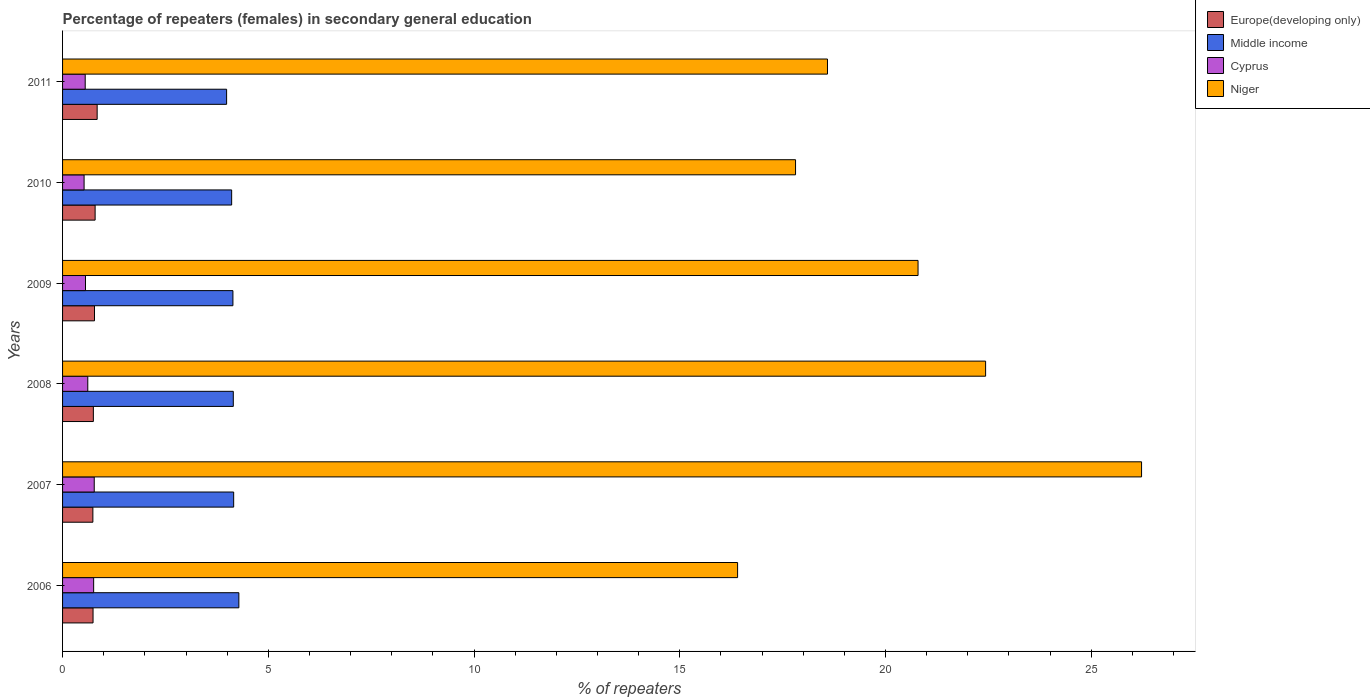How many different coloured bars are there?
Make the answer very short. 4. How many groups of bars are there?
Keep it short and to the point. 6. Are the number of bars per tick equal to the number of legend labels?
Provide a short and direct response. Yes. What is the label of the 3rd group of bars from the top?
Make the answer very short. 2009. What is the percentage of female repeaters in Europe(developing only) in 2008?
Keep it short and to the point. 0.75. Across all years, what is the maximum percentage of female repeaters in Europe(developing only)?
Your answer should be compact. 0.84. Across all years, what is the minimum percentage of female repeaters in Cyprus?
Make the answer very short. 0.52. What is the total percentage of female repeaters in Cyprus in the graph?
Your response must be concise. 3.77. What is the difference between the percentage of female repeaters in Cyprus in 2007 and that in 2009?
Keep it short and to the point. 0.21. What is the difference between the percentage of female repeaters in Cyprus in 2009 and the percentage of female repeaters in Niger in 2007?
Keep it short and to the point. -25.67. What is the average percentage of female repeaters in Niger per year?
Provide a succinct answer. 20.38. In the year 2007, what is the difference between the percentage of female repeaters in Niger and percentage of female repeaters in Europe(developing only)?
Provide a succinct answer. 25.49. In how many years, is the percentage of female repeaters in Niger greater than 3 %?
Make the answer very short. 6. What is the ratio of the percentage of female repeaters in Niger in 2009 to that in 2011?
Your answer should be compact. 1.12. Is the percentage of female repeaters in Europe(developing only) in 2009 less than that in 2010?
Make the answer very short. Yes. What is the difference between the highest and the second highest percentage of female repeaters in Europe(developing only)?
Give a very brief answer. 0.05. What is the difference between the highest and the lowest percentage of female repeaters in Europe(developing only)?
Provide a succinct answer. 0.1. Is the sum of the percentage of female repeaters in Cyprus in 2007 and 2009 greater than the maximum percentage of female repeaters in Niger across all years?
Provide a succinct answer. No. What does the 1st bar from the top in 2009 represents?
Give a very brief answer. Niger. What does the 3rd bar from the bottom in 2008 represents?
Make the answer very short. Cyprus. Are all the bars in the graph horizontal?
Provide a short and direct response. Yes. What is the difference between two consecutive major ticks on the X-axis?
Provide a succinct answer. 5. Does the graph contain any zero values?
Your answer should be compact. No. Does the graph contain grids?
Your answer should be compact. No. Where does the legend appear in the graph?
Make the answer very short. Top right. How many legend labels are there?
Your answer should be compact. 4. How are the legend labels stacked?
Offer a very short reply. Vertical. What is the title of the graph?
Make the answer very short. Percentage of repeaters (females) in secondary general education. What is the label or title of the X-axis?
Provide a short and direct response. % of repeaters. What is the label or title of the Y-axis?
Provide a short and direct response. Years. What is the % of repeaters of Europe(developing only) in 2006?
Your answer should be very brief. 0.74. What is the % of repeaters of Middle income in 2006?
Your answer should be compact. 4.28. What is the % of repeaters of Cyprus in 2006?
Offer a terse response. 0.76. What is the % of repeaters of Niger in 2006?
Keep it short and to the point. 16.41. What is the % of repeaters in Europe(developing only) in 2007?
Make the answer very short. 0.74. What is the % of repeaters in Middle income in 2007?
Offer a very short reply. 4.16. What is the % of repeaters of Cyprus in 2007?
Make the answer very short. 0.77. What is the % of repeaters in Niger in 2007?
Your response must be concise. 26.22. What is the % of repeaters of Europe(developing only) in 2008?
Keep it short and to the point. 0.75. What is the % of repeaters of Middle income in 2008?
Your answer should be very brief. 4.15. What is the % of repeaters of Cyprus in 2008?
Provide a short and direct response. 0.61. What is the % of repeaters in Niger in 2008?
Your answer should be compact. 22.43. What is the % of repeaters in Europe(developing only) in 2009?
Provide a succinct answer. 0.78. What is the % of repeaters of Middle income in 2009?
Make the answer very short. 4.14. What is the % of repeaters in Cyprus in 2009?
Your answer should be compact. 0.56. What is the % of repeaters of Niger in 2009?
Your answer should be compact. 20.79. What is the % of repeaters in Europe(developing only) in 2010?
Keep it short and to the point. 0.79. What is the % of repeaters of Middle income in 2010?
Make the answer very short. 4.11. What is the % of repeaters in Cyprus in 2010?
Your response must be concise. 0.52. What is the % of repeaters in Niger in 2010?
Your answer should be compact. 17.81. What is the % of repeaters of Europe(developing only) in 2011?
Offer a terse response. 0.84. What is the % of repeaters of Middle income in 2011?
Ensure brevity in your answer.  3.99. What is the % of repeaters of Cyprus in 2011?
Offer a terse response. 0.55. What is the % of repeaters in Niger in 2011?
Keep it short and to the point. 18.59. Across all years, what is the maximum % of repeaters of Europe(developing only)?
Keep it short and to the point. 0.84. Across all years, what is the maximum % of repeaters of Middle income?
Your response must be concise. 4.28. Across all years, what is the maximum % of repeaters of Cyprus?
Give a very brief answer. 0.77. Across all years, what is the maximum % of repeaters of Niger?
Your response must be concise. 26.22. Across all years, what is the minimum % of repeaters in Europe(developing only)?
Provide a succinct answer. 0.74. Across all years, what is the minimum % of repeaters of Middle income?
Make the answer very short. 3.99. Across all years, what is the minimum % of repeaters in Cyprus?
Provide a succinct answer. 0.52. Across all years, what is the minimum % of repeaters of Niger?
Keep it short and to the point. 16.41. What is the total % of repeaters of Europe(developing only) in the graph?
Make the answer very short. 4.63. What is the total % of repeaters in Middle income in the graph?
Keep it short and to the point. 24.83. What is the total % of repeaters in Cyprus in the graph?
Provide a succinct answer. 3.77. What is the total % of repeaters of Niger in the graph?
Your answer should be compact. 122.25. What is the difference between the % of repeaters of Europe(developing only) in 2006 and that in 2007?
Ensure brevity in your answer.  0. What is the difference between the % of repeaters of Middle income in 2006 and that in 2007?
Offer a very short reply. 0.13. What is the difference between the % of repeaters in Cyprus in 2006 and that in 2007?
Offer a very short reply. -0.01. What is the difference between the % of repeaters of Niger in 2006 and that in 2007?
Your answer should be very brief. -9.82. What is the difference between the % of repeaters in Europe(developing only) in 2006 and that in 2008?
Provide a succinct answer. -0.01. What is the difference between the % of repeaters in Middle income in 2006 and that in 2008?
Provide a short and direct response. 0.14. What is the difference between the % of repeaters in Cyprus in 2006 and that in 2008?
Keep it short and to the point. 0.14. What is the difference between the % of repeaters in Niger in 2006 and that in 2008?
Give a very brief answer. -6.03. What is the difference between the % of repeaters in Europe(developing only) in 2006 and that in 2009?
Offer a terse response. -0.04. What is the difference between the % of repeaters of Middle income in 2006 and that in 2009?
Your answer should be compact. 0.14. What is the difference between the % of repeaters in Cyprus in 2006 and that in 2009?
Make the answer very short. 0.2. What is the difference between the % of repeaters of Niger in 2006 and that in 2009?
Provide a short and direct response. -4.39. What is the difference between the % of repeaters of Europe(developing only) in 2006 and that in 2010?
Your response must be concise. -0.05. What is the difference between the % of repeaters in Middle income in 2006 and that in 2010?
Make the answer very short. 0.17. What is the difference between the % of repeaters of Cyprus in 2006 and that in 2010?
Make the answer very short. 0.23. What is the difference between the % of repeaters of Niger in 2006 and that in 2010?
Your answer should be very brief. -1.41. What is the difference between the % of repeaters of Europe(developing only) in 2006 and that in 2011?
Offer a terse response. -0.1. What is the difference between the % of repeaters in Middle income in 2006 and that in 2011?
Give a very brief answer. 0.3. What is the difference between the % of repeaters of Cyprus in 2006 and that in 2011?
Offer a terse response. 0.21. What is the difference between the % of repeaters in Niger in 2006 and that in 2011?
Keep it short and to the point. -2.18. What is the difference between the % of repeaters of Europe(developing only) in 2007 and that in 2008?
Your answer should be very brief. -0.01. What is the difference between the % of repeaters of Middle income in 2007 and that in 2008?
Your response must be concise. 0.01. What is the difference between the % of repeaters of Cyprus in 2007 and that in 2008?
Give a very brief answer. 0.16. What is the difference between the % of repeaters of Niger in 2007 and that in 2008?
Your response must be concise. 3.79. What is the difference between the % of repeaters of Europe(developing only) in 2007 and that in 2009?
Make the answer very short. -0.04. What is the difference between the % of repeaters in Middle income in 2007 and that in 2009?
Your answer should be very brief. 0.02. What is the difference between the % of repeaters of Cyprus in 2007 and that in 2009?
Your answer should be compact. 0.21. What is the difference between the % of repeaters of Niger in 2007 and that in 2009?
Ensure brevity in your answer.  5.43. What is the difference between the % of repeaters of Europe(developing only) in 2007 and that in 2010?
Provide a succinct answer. -0.05. What is the difference between the % of repeaters of Middle income in 2007 and that in 2010?
Your answer should be very brief. 0.05. What is the difference between the % of repeaters in Cyprus in 2007 and that in 2010?
Keep it short and to the point. 0.25. What is the difference between the % of repeaters of Niger in 2007 and that in 2010?
Make the answer very short. 8.41. What is the difference between the % of repeaters of Europe(developing only) in 2007 and that in 2011?
Your answer should be compact. -0.1. What is the difference between the % of repeaters of Middle income in 2007 and that in 2011?
Provide a short and direct response. 0.17. What is the difference between the % of repeaters in Cyprus in 2007 and that in 2011?
Ensure brevity in your answer.  0.22. What is the difference between the % of repeaters of Niger in 2007 and that in 2011?
Ensure brevity in your answer.  7.63. What is the difference between the % of repeaters in Europe(developing only) in 2008 and that in 2009?
Make the answer very short. -0.03. What is the difference between the % of repeaters of Middle income in 2008 and that in 2009?
Offer a very short reply. 0.01. What is the difference between the % of repeaters of Cyprus in 2008 and that in 2009?
Provide a short and direct response. 0.06. What is the difference between the % of repeaters of Niger in 2008 and that in 2009?
Keep it short and to the point. 1.64. What is the difference between the % of repeaters of Europe(developing only) in 2008 and that in 2010?
Your response must be concise. -0.04. What is the difference between the % of repeaters of Middle income in 2008 and that in 2010?
Offer a terse response. 0.04. What is the difference between the % of repeaters of Cyprus in 2008 and that in 2010?
Provide a succinct answer. 0.09. What is the difference between the % of repeaters in Niger in 2008 and that in 2010?
Ensure brevity in your answer.  4.62. What is the difference between the % of repeaters of Europe(developing only) in 2008 and that in 2011?
Offer a terse response. -0.09. What is the difference between the % of repeaters in Middle income in 2008 and that in 2011?
Your answer should be very brief. 0.16. What is the difference between the % of repeaters in Cyprus in 2008 and that in 2011?
Ensure brevity in your answer.  0.06. What is the difference between the % of repeaters in Niger in 2008 and that in 2011?
Ensure brevity in your answer.  3.84. What is the difference between the % of repeaters in Europe(developing only) in 2009 and that in 2010?
Your answer should be very brief. -0.02. What is the difference between the % of repeaters in Middle income in 2009 and that in 2010?
Ensure brevity in your answer.  0.03. What is the difference between the % of repeaters in Cyprus in 2009 and that in 2010?
Offer a terse response. 0.03. What is the difference between the % of repeaters in Niger in 2009 and that in 2010?
Keep it short and to the point. 2.98. What is the difference between the % of repeaters of Europe(developing only) in 2009 and that in 2011?
Offer a very short reply. -0.06. What is the difference between the % of repeaters in Middle income in 2009 and that in 2011?
Ensure brevity in your answer.  0.15. What is the difference between the % of repeaters of Cyprus in 2009 and that in 2011?
Keep it short and to the point. 0.01. What is the difference between the % of repeaters in Niger in 2009 and that in 2011?
Give a very brief answer. 2.2. What is the difference between the % of repeaters in Europe(developing only) in 2010 and that in 2011?
Give a very brief answer. -0.05. What is the difference between the % of repeaters of Middle income in 2010 and that in 2011?
Keep it short and to the point. 0.12. What is the difference between the % of repeaters in Cyprus in 2010 and that in 2011?
Provide a succinct answer. -0.03. What is the difference between the % of repeaters in Niger in 2010 and that in 2011?
Keep it short and to the point. -0.78. What is the difference between the % of repeaters of Europe(developing only) in 2006 and the % of repeaters of Middle income in 2007?
Ensure brevity in your answer.  -3.42. What is the difference between the % of repeaters in Europe(developing only) in 2006 and the % of repeaters in Cyprus in 2007?
Provide a short and direct response. -0.03. What is the difference between the % of repeaters of Europe(developing only) in 2006 and the % of repeaters of Niger in 2007?
Ensure brevity in your answer.  -25.48. What is the difference between the % of repeaters of Middle income in 2006 and the % of repeaters of Cyprus in 2007?
Your response must be concise. 3.51. What is the difference between the % of repeaters in Middle income in 2006 and the % of repeaters in Niger in 2007?
Give a very brief answer. -21.94. What is the difference between the % of repeaters of Cyprus in 2006 and the % of repeaters of Niger in 2007?
Keep it short and to the point. -25.47. What is the difference between the % of repeaters in Europe(developing only) in 2006 and the % of repeaters in Middle income in 2008?
Ensure brevity in your answer.  -3.41. What is the difference between the % of repeaters of Europe(developing only) in 2006 and the % of repeaters of Cyprus in 2008?
Offer a terse response. 0.13. What is the difference between the % of repeaters of Europe(developing only) in 2006 and the % of repeaters of Niger in 2008?
Keep it short and to the point. -21.69. What is the difference between the % of repeaters of Middle income in 2006 and the % of repeaters of Cyprus in 2008?
Offer a very short reply. 3.67. What is the difference between the % of repeaters in Middle income in 2006 and the % of repeaters in Niger in 2008?
Your response must be concise. -18.15. What is the difference between the % of repeaters of Cyprus in 2006 and the % of repeaters of Niger in 2008?
Provide a succinct answer. -21.68. What is the difference between the % of repeaters of Europe(developing only) in 2006 and the % of repeaters of Middle income in 2009?
Keep it short and to the point. -3.4. What is the difference between the % of repeaters in Europe(developing only) in 2006 and the % of repeaters in Cyprus in 2009?
Your response must be concise. 0.18. What is the difference between the % of repeaters in Europe(developing only) in 2006 and the % of repeaters in Niger in 2009?
Your answer should be compact. -20.05. What is the difference between the % of repeaters in Middle income in 2006 and the % of repeaters in Cyprus in 2009?
Provide a short and direct response. 3.73. What is the difference between the % of repeaters of Middle income in 2006 and the % of repeaters of Niger in 2009?
Your answer should be compact. -16.51. What is the difference between the % of repeaters in Cyprus in 2006 and the % of repeaters in Niger in 2009?
Offer a terse response. -20.03. What is the difference between the % of repeaters in Europe(developing only) in 2006 and the % of repeaters in Middle income in 2010?
Your answer should be very brief. -3.37. What is the difference between the % of repeaters in Europe(developing only) in 2006 and the % of repeaters in Cyprus in 2010?
Offer a terse response. 0.22. What is the difference between the % of repeaters in Europe(developing only) in 2006 and the % of repeaters in Niger in 2010?
Your response must be concise. -17.07. What is the difference between the % of repeaters in Middle income in 2006 and the % of repeaters in Cyprus in 2010?
Your answer should be very brief. 3.76. What is the difference between the % of repeaters of Middle income in 2006 and the % of repeaters of Niger in 2010?
Ensure brevity in your answer.  -13.53. What is the difference between the % of repeaters in Cyprus in 2006 and the % of repeaters in Niger in 2010?
Provide a succinct answer. -17.06. What is the difference between the % of repeaters in Europe(developing only) in 2006 and the % of repeaters in Middle income in 2011?
Your response must be concise. -3.25. What is the difference between the % of repeaters in Europe(developing only) in 2006 and the % of repeaters in Cyprus in 2011?
Ensure brevity in your answer.  0.19. What is the difference between the % of repeaters of Europe(developing only) in 2006 and the % of repeaters of Niger in 2011?
Give a very brief answer. -17.85. What is the difference between the % of repeaters of Middle income in 2006 and the % of repeaters of Cyprus in 2011?
Your answer should be compact. 3.73. What is the difference between the % of repeaters of Middle income in 2006 and the % of repeaters of Niger in 2011?
Give a very brief answer. -14.31. What is the difference between the % of repeaters of Cyprus in 2006 and the % of repeaters of Niger in 2011?
Your response must be concise. -17.83. What is the difference between the % of repeaters of Europe(developing only) in 2007 and the % of repeaters of Middle income in 2008?
Your response must be concise. -3.41. What is the difference between the % of repeaters of Europe(developing only) in 2007 and the % of repeaters of Cyprus in 2008?
Offer a very short reply. 0.12. What is the difference between the % of repeaters in Europe(developing only) in 2007 and the % of repeaters in Niger in 2008?
Ensure brevity in your answer.  -21.7. What is the difference between the % of repeaters of Middle income in 2007 and the % of repeaters of Cyprus in 2008?
Offer a very short reply. 3.55. What is the difference between the % of repeaters in Middle income in 2007 and the % of repeaters in Niger in 2008?
Offer a very short reply. -18.27. What is the difference between the % of repeaters of Cyprus in 2007 and the % of repeaters of Niger in 2008?
Your answer should be very brief. -21.66. What is the difference between the % of repeaters in Europe(developing only) in 2007 and the % of repeaters in Middle income in 2009?
Make the answer very short. -3.4. What is the difference between the % of repeaters of Europe(developing only) in 2007 and the % of repeaters of Cyprus in 2009?
Make the answer very short. 0.18. What is the difference between the % of repeaters of Europe(developing only) in 2007 and the % of repeaters of Niger in 2009?
Your answer should be compact. -20.05. What is the difference between the % of repeaters of Middle income in 2007 and the % of repeaters of Cyprus in 2009?
Make the answer very short. 3.6. What is the difference between the % of repeaters of Middle income in 2007 and the % of repeaters of Niger in 2009?
Provide a succinct answer. -16.63. What is the difference between the % of repeaters in Cyprus in 2007 and the % of repeaters in Niger in 2009?
Ensure brevity in your answer.  -20.02. What is the difference between the % of repeaters of Europe(developing only) in 2007 and the % of repeaters of Middle income in 2010?
Your answer should be very brief. -3.37. What is the difference between the % of repeaters in Europe(developing only) in 2007 and the % of repeaters in Cyprus in 2010?
Ensure brevity in your answer.  0.21. What is the difference between the % of repeaters in Europe(developing only) in 2007 and the % of repeaters in Niger in 2010?
Ensure brevity in your answer.  -17.08. What is the difference between the % of repeaters of Middle income in 2007 and the % of repeaters of Cyprus in 2010?
Your answer should be compact. 3.64. What is the difference between the % of repeaters in Middle income in 2007 and the % of repeaters in Niger in 2010?
Provide a short and direct response. -13.66. What is the difference between the % of repeaters in Cyprus in 2007 and the % of repeaters in Niger in 2010?
Your response must be concise. -17.04. What is the difference between the % of repeaters of Europe(developing only) in 2007 and the % of repeaters of Middle income in 2011?
Your answer should be very brief. -3.25. What is the difference between the % of repeaters of Europe(developing only) in 2007 and the % of repeaters of Cyprus in 2011?
Your answer should be compact. 0.19. What is the difference between the % of repeaters in Europe(developing only) in 2007 and the % of repeaters in Niger in 2011?
Your answer should be very brief. -17.85. What is the difference between the % of repeaters in Middle income in 2007 and the % of repeaters in Cyprus in 2011?
Keep it short and to the point. 3.61. What is the difference between the % of repeaters in Middle income in 2007 and the % of repeaters in Niger in 2011?
Provide a short and direct response. -14.43. What is the difference between the % of repeaters in Cyprus in 2007 and the % of repeaters in Niger in 2011?
Make the answer very short. -17.82. What is the difference between the % of repeaters in Europe(developing only) in 2008 and the % of repeaters in Middle income in 2009?
Ensure brevity in your answer.  -3.39. What is the difference between the % of repeaters in Europe(developing only) in 2008 and the % of repeaters in Cyprus in 2009?
Give a very brief answer. 0.19. What is the difference between the % of repeaters in Europe(developing only) in 2008 and the % of repeaters in Niger in 2009?
Ensure brevity in your answer.  -20.04. What is the difference between the % of repeaters of Middle income in 2008 and the % of repeaters of Cyprus in 2009?
Make the answer very short. 3.59. What is the difference between the % of repeaters of Middle income in 2008 and the % of repeaters of Niger in 2009?
Keep it short and to the point. -16.64. What is the difference between the % of repeaters of Cyprus in 2008 and the % of repeaters of Niger in 2009?
Provide a short and direct response. -20.18. What is the difference between the % of repeaters in Europe(developing only) in 2008 and the % of repeaters in Middle income in 2010?
Your answer should be compact. -3.36. What is the difference between the % of repeaters of Europe(developing only) in 2008 and the % of repeaters of Cyprus in 2010?
Give a very brief answer. 0.23. What is the difference between the % of repeaters of Europe(developing only) in 2008 and the % of repeaters of Niger in 2010?
Offer a very short reply. -17.07. What is the difference between the % of repeaters of Middle income in 2008 and the % of repeaters of Cyprus in 2010?
Your response must be concise. 3.63. What is the difference between the % of repeaters of Middle income in 2008 and the % of repeaters of Niger in 2010?
Provide a succinct answer. -13.66. What is the difference between the % of repeaters in Cyprus in 2008 and the % of repeaters in Niger in 2010?
Ensure brevity in your answer.  -17.2. What is the difference between the % of repeaters in Europe(developing only) in 2008 and the % of repeaters in Middle income in 2011?
Provide a short and direct response. -3.24. What is the difference between the % of repeaters of Europe(developing only) in 2008 and the % of repeaters of Cyprus in 2011?
Provide a succinct answer. 0.2. What is the difference between the % of repeaters of Europe(developing only) in 2008 and the % of repeaters of Niger in 2011?
Keep it short and to the point. -17.84. What is the difference between the % of repeaters of Middle income in 2008 and the % of repeaters of Cyprus in 2011?
Ensure brevity in your answer.  3.6. What is the difference between the % of repeaters of Middle income in 2008 and the % of repeaters of Niger in 2011?
Your answer should be compact. -14.44. What is the difference between the % of repeaters of Cyprus in 2008 and the % of repeaters of Niger in 2011?
Offer a terse response. -17.98. What is the difference between the % of repeaters in Europe(developing only) in 2009 and the % of repeaters in Middle income in 2010?
Your response must be concise. -3.33. What is the difference between the % of repeaters in Europe(developing only) in 2009 and the % of repeaters in Cyprus in 2010?
Provide a short and direct response. 0.25. What is the difference between the % of repeaters of Europe(developing only) in 2009 and the % of repeaters of Niger in 2010?
Your answer should be compact. -17.04. What is the difference between the % of repeaters of Middle income in 2009 and the % of repeaters of Cyprus in 2010?
Make the answer very short. 3.62. What is the difference between the % of repeaters of Middle income in 2009 and the % of repeaters of Niger in 2010?
Offer a very short reply. -13.67. What is the difference between the % of repeaters of Cyprus in 2009 and the % of repeaters of Niger in 2010?
Keep it short and to the point. -17.26. What is the difference between the % of repeaters in Europe(developing only) in 2009 and the % of repeaters in Middle income in 2011?
Give a very brief answer. -3.21. What is the difference between the % of repeaters in Europe(developing only) in 2009 and the % of repeaters in Cyprus in 2011?
Keep it short and to the point. 0.23. What is the difference between the % of repeaters of Europe(developing only) in 2009 and the % of repeaters of Niger in 2011?
Offer a very short reply. -17.81. What is the difference between the % of repeaters of Middle income in 2009 and the % of repeaters of Cyprus in 2011?
Offer a very short reply. 3.59. What is the difference between the % of repeaters of Middle income in 2009 and the % of repeaters of Niger in 2011?
Offer a terse response. -14.45. What is the difference between the % of repeaters in Cyprus in 2009 and the % of repeaters in Niger in 2011?
Provide a short and direct response. -18.03. What is the difference between the % of repeaters of Europe(developing only) in 2010 and the % of repeaters of Middle income in 2011?
Give a very brief answer. -3.2. What is the difference between the % of repeaters in Europe(developing only) in 2010 and the % of repeaters in Cyprus in 2011?
Offer a very short reply. 0.24. What is the difference between the % of repeaters in Europe(developing only) in 2010 and the % of repeaters in Niger in 2011?
Ensure brevity in your answer.  -17.8. What is the difference between the % of repeaters of Middle income in 2010 and the % of repeaters of Cyprus in 2011?
Ensure brevity in your answer.  3.56. What is the difference between the % of repeaters in Middle income in 2010 and the % of repeaters in Niger in 2011?
Your response must be concise. -14.48. What is the difference between the % of repeaters of Cyprus in 2010 and the % of repeaters of Niger in 2011?
Your answer should be compact. -18.07. What is the average % of repeaters in Europe(developing only) per year?
Your response must be concise. 0.77. What is the average % of repeaters of Middle income per year?
Provide a succinct answer. 4.14. What is the average % of repeaters of Cyprus per year?
Provide a short and direct response. 0.63. What is the average % of repeaters of Niger per year?
Your answer should be very brief. 20.38. In the year 2006, what is the difference between the % of repeaters of Europe(developing only) and % of repeaters of Middle income?
Make the answer very short. -3.54. In the year 2006, what is the difference between the % of repeaters in Europe(developing only) and % of repeaters in Cyprus?
Ensure brevity in your answer.  -0.01. In the year 2006, what is the difference between the % of repeaters in Europe(developing only) and % of repeaters in Niger?
Ensure brevity in your answer.  -15.66. In the year 2006, what is the difference between the % of repeaters in Middle income and % of repeaters in Cyprus?
Ensure brevity in your answer.  3.53. In the year 2006, what is the difference between the % of repeaters of Middle income and % of repeaters of Niger?
Ensure brevity in your answer.  -12.12. In the year 2006, what is the difference between the % of repeaters in Cyprus and % of repeaters in Niger?
Your answer should be very brief. -15.65. In the year 2007, what is the difference between the % of repeaters of Europe(developing only) and % of repeaters of Middle income?
Offer a very short reply. -3.42. In the year 2007, what is the difference between the % of repeaters in Europe(developing only) and % of repeaters in Cyprus?
Keep it short and to the point. -0.03. In the year 2007, what is the difference between the % of repeaters of Europe(developing only) and % of repeaters of Niger?
Offer a very short reply. -25.49. In the year 2007, what is the difference between the % of repeaters in Middle income and % of repeaters in Cyprus?
Offer a very short reply. 3.39. In the year 2007, what is the difference between the % of repeaters in Middle income and % of repeaters in Niger?
Your response must be concise. -22.06. In the year 2007, what is the difference between the % of repeaters in Cyprus and % of repeaters in Niger?
Your answer should be compact. -25.45. In the year 2008, what is the difference between the % of repeaters of Europe(developing only) and % of repeaters of Middle income?
Ensure brevity in your answer.  -3.4. In the year 2008, what is the difference between the % of repeaters of Europe(developing only) and % of repeaters of Cyprus?
Your answer should be compact. 0.14. In the year 2008, what is the difference between the % of repeaters of Europe(developing only) and % of repeaters of Niger?
Your answer should be very brief. -21.68. In the year 2008, what is the difference between the % of repeaters in Middle income and % of repeaters in Cyprus?
Provide a short and direct response. 3.54. In the year 2008, what is the difference between the % of repeaters in Middle income and % of repeaters in Niger?
Provide a succinct answer. -18.28. In the year 2008, what is the difference between the % of repeaters of Cyprus and % of repeaters of Niger?
Your response must be concise. -21.82. In the year 2009, what is the difference between the % of repeaters of Europe(developing only) and % of repeaters of Middle income?
Ensure brevity in your answer.  -3.36. In the year 2009, what is the difference between the % of repeaters in Europe(developing only) and % of repeaters in Cyprus?
Make the answer very short. 0.22. In the year 2009, what is the difference between the % of repeaters in Europe(developing only) and % of repeaters in Niger?
Keep it short and to the point. -20.01. In the year 2009, what is the difference between the % of repeaters of Middle income and % of repeaters of Cyprus?
Offer a terse response. 3.58. In the year 2009, what is the difference between the % of repeaters of Middle income and % of repeaters of Niger?
Provide a succinct answer. -16.65. In the year 2009, what is the difference between the % of repeaters in Cyprus and % of repeaters in Niger?
Your answer should be very brief. -20.23. In the year 2010, what is the difference between the % of repeaters of Europe(developing only) and % of repeaters of Middle income?
Keep it short and to the point. -3.32. In the year 2010, what is the difference between the % of repeaters of Europe(developing only) and % of repeaters of Cyprus?
Provide a succinct answer. 0.27. In the year 2010, what is the difference between the % of repeaters in Europe(developing only) and % of repeaters in Niger?
Give a very brief answer. -17.02. In the year 2010, what is the difference between the % of repeaters in Middle income and % of repeaters in Cyprus?
Make the answer very short. 3.59. In the year 2010, what is the difference between the % of repeaters of Middle income and % of repeaters of Niger?
Provide a short and direct response. -13.7. In the year 2010, what is the difference between the % of repeaters in Cyprus and % of repeaters in Niger?
Offer a terse response. -17.29. In the year 2011, what is the difference between the % of repeaters in Europe(developing only) and % of repeaters in Middle income?
Your answer should be very brief. -3.15. In the year 2011, what is the difference between the % of repeaters in Europe(developing only) and % of repeaters in Cyprus?
Offer a very short reply. 0.29. In the year 2011, what is the difference between the % of repeaters in Europe(developing only) and % of repeaters in Niger?
Your answer should be very brief. -17.75. In the year 2011, what is the difference between the % of repeaters in Middle income and % of repeaters in Cyprus?
Ensure brevity in your answer.  3.44. In the year 2011, what is the difference between the % of repeaters in Middle income and % of repeaters in Niger?
Make the answer very short. -14.6. In the year 2011, what is the difference between the % of repeaters of Cyprus and % of repeaters of Niger?
Provide a succinct answer. -18.04. What is the ratio of the % of repeaters in Europe(developing only) in 2006 to that in 2007?
Offer a terse response. 1.01. What is the ratio of the % of repeaters in Middle income in 2006 to that in 2007?
Make the answer very short. 1.03. What is the ratio of the % of repeaters of Cyprus in 2006 to that in 2007?
Give a very brief answer. 0.98. What is the ratio of the % of repeaters in Niger in 2006 to that in 2007?
Your response must be concise. 0.63. What is the ratio of the % of repeaters of Europe(developing only) in 2006 to that in 2008?
Your response must be concise. 0.99. What is the ratio of the % of repeaters of Middle income in 2006 to that in 2008?
Make the answer very short. 1.03. What is the ratio of the % of repeaters of Cyprus in 2006 to that in 2008?
Your answer should be compact. 1.23. What is the ratio of the % of repeaters in Niger in 2006 to that in 2008?
Offer a very short reply. 0.73. What is the ratio of the % of repeaters of Europe(developing only) in 2006 to that in 2009?
Your answer should be very brief. 0.95. What is the ratio of the % of repeaters in Middle income in 2006 to that in 2009?
Keep it short and to the point. 1.03. What is the ratio of the % of repeaters in Cyprus in 2006 to that in 2009?
Make the answer very short. 1.36. What is the ratio of the % of repeaters in Niger in 2006 to that in 2009?
Make the answer very short. 0.79. What is the ratio of the % of repeaters in Europe(developing only) in 2006 to that in 2010?
Make the answer very short. 0.94. What is the ratio of the % of repeaters of Middle income in 2006 to that in 2010?
Ensure brevity in your answer.  1.04. What is the ratio of the % of repeaters in Cyprus in 2006 to that in 2010?
Offer a very short reply. 1.44. What is the ratio of the % of repeaters of Niger in 2006 to that in 2010?
Offer a terse response. 0.92. What is the ratio of the % of repeaters in Europe(developing only) in 2006 to that in 2011?
Provide a short and direct response. 0.88. What is the ratio of the % of repeaters in Middle income in 2006 to that in 2011?
Your answer should be compact. 1.07. What is the ratio of the % of repeaters in Cyprus in 2006 to that in 2011?
Provide a succinct answer. 1.37. What is the ratio of the % of repeaters in Niger in 2006 to that in 2011?
Give a very brief answer. 0.88. What is the ratio of the % of repeaters of Europe(developing only) in 2007 to that in 2008?
Offer a terse response. 0.98. What is the ratio of the % of repeaters of Cyprus in 2007 to that in 2008?
Your response must be concise. 1.26. What is the ratio of the % of repeaters in Niger in 2007 to that in 2008?
Offer a terse response. 1.17. What is the ratio of the % of repeaters in Europe(developing only) in 2007 to that in 2009?
Keep it short and to the point. 0.95. What is the ratio of the % of repeaters of Middle income in 2007 to that in 2009?
Your answer should be very brief. 1. What is the ratio of the % of repeaters in Cyprus in 2007 to that in 2009?
Your answer should be compact. 1.38. What is the ratio of the % of repeaters in Niger in 2007 to that in 2009?
Your response must be concise. 1.26. What is the ratio of the % of repeaters in Europe(developing only) in 2007 to that in 2010?
Your answer should be very brief. 0.93. What is the ratio of the % of repeaters in Middle income in 2007 to that in 2010?
Provide a succinct answer. 1.01. What is the ratio of the % of repeaters of Cyprus in 2007 to that in 2010?
Make the answer very short. 1.47. What is the ratio of the % of repeaters of Niger in 2007 to that in 2010?
Give a very brief answer. 1.47. What is the ratio of the % of repeaters in Europe(developing only) in 2007 to that in 2011?
Your answer should be compact. 0.88. What is the ratio of the % of repeaters of Middle income in 2007 to that in 2011?
Make the answer very short. 1.04. What is the ratio of the % of repeaters in Cyprus in 2007 to that in 2011?
Offer a very short reply. 1.4. What is the ratio of the % of repeaters in Niger in 2007 to that in 2011?
Your answer should be compact. 1.41. What is the ratio of the % of repeaters in Europe(developing only) in 2008 to that in 2009?
Your answer should be very brief. 0.96. What is the ratio of the % of repeaters in Cyprus in 2008 to that in 2009?
Provide a succinct answer. 1.1. What is the ratio of the % of repeaters of Niger in 2008 to that in 2009?
Give a very brief answer. 1.08. What is the ratio of the % of repeaters of Europe(developing only) in 2008 to that in 2010?
Make the answer very short. 0.95. What is the ratio of the % of repeaters in Middle income in 2008 to that in 2010?
Offer a very short reply. 1.01. What is the ratio of the % of repeaters of Cyprus in 2008 to that in 2010?
Provide a succinct answer. 1.17. What is the ratio of the % of repeaters in Niger in 2008 to that in 2010?
Offer a very short reply. 1.26. What is the ratio of the % of repeaters in Europe(developing only) in 2008 to that in 2011?
Give a very brief answer. 0.89. What is the ratio of the % of repeaters of Middle income in 2008 to that in 2011?
Your answer should be compact. 1.04. What is the ratio of the % of repeaters of Cyprus in 2008 to that in 2011?
Your response must be concise. 1.11. What is the ratio of the % of repeaters in Niger in 2008 to that in 2011?
Provide a succinct answer. 1.21. What is the ratio of the % of repeaters in Middle income in 2009 to that in 2010?
Ensure brevity in your answer.  1.01. What is the ratio of the % of repeaters in Cyprus in 2009 to that in 2010?
Ensure brevity in your answer.  1.07. What is the ratio of the % of repeaters of Niger in 2009 to that in 2010?
Keep it short and to the point. 1.17. What is the ratio of the % of repeaters of Europe(developing only) in 2009 to that in 2011?
Give a very brief answer. 0.92. What is the ratio of the % of repeaters in Middle income in 2009 to that in 2011?
Provide a succinct answer. 1.04. What is the ratio of the % of repeaters of Cyprus in 2009 to that in 2011?
Give a very brief answer. 1.01. What is the ratio of the % of repeaters in Niger in 2009 to that in 2011?
Make the answer very short. 1.12. What is the ratio of the % of repeaters of Europe(developing only) in 2010 to that in 2011?
Provide a succinct answer. 0.94. What is the ratio of the % of repeaters in Middle income in 2010 to that in 2011?
Keep it short and to the point. 1.03. What is the ratio of the % of repeaters of Cyprus in 2010 to that in 2011?
Make the answer very short. 0.95. What is the ratio of the % of repeaters of Niger in 2010 to that in 2011?
Keep it short and to the point. 0.96. What is the difference between the highest and the second highest % of repeaters of Europe(developing only)?
Ensure brevity in your answer.  0.05. What is the difference between the highest and the second highest % of repeaters in Middle income?
Make the answer very short. 0.13. What is the difference between the highest and the second highest % of repeaters of Cyprus?
Give a very brief answer. 0.01. What is the difference between the highest and the second highest % of repeaters in Niger?
Offer a very short reply. 3.79. What is the difference between the highest and the lowest % of repeaters in Europe(developing only)?
Offer a very short reply. 0.1. What is the difference between the highest and the lowest % of repeaters in Middle income?
Your answer should be very brief. 0.3. What is the difference between the highest and the lowest % of repeaters in Cyprus?
Give a very brief answer. 0.25. What is the difference between the highest and the lowest % of repeaters in Niger?
Your response must be concise. 9.82. 